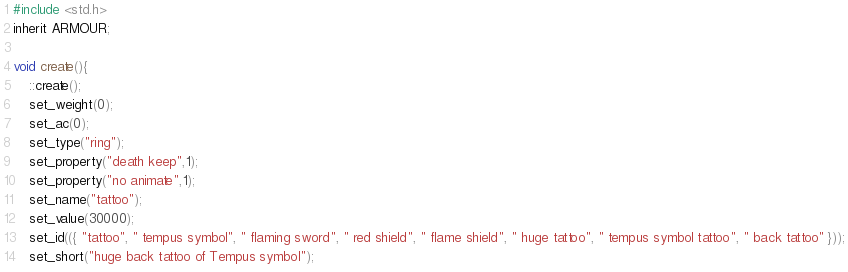<code> <loc_0><loc_0><loc_500><loc_500><_C_>#include <std.h>
inherit ARMOUR;

void create(){
	::create();
	set_weight(0);
	set_ac(0);
	set_type("ring");
	set_property("death keep",1);
	set_property("no animate",1);
	set_name("tattoo");
	set_value(30000);
	set_id(({ "tattoo", " tempus symbol", " flaming sword", " red shield", " flame shield", " huge tattoo", " tempus symbol tattoo", " back tattoo" }));
	set_short("huge back tattoo of Tempus symbol");
</code> 